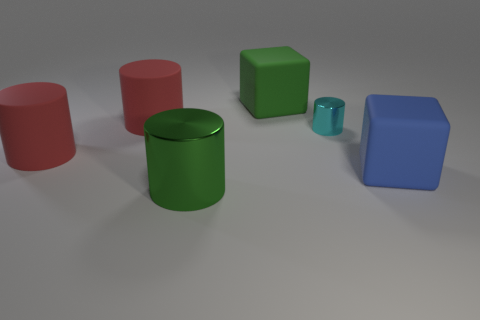What size is the rubber cylinder that is behind the small metal cylinder?
Your answer should be very brief. Large. What is the shape of the green object behind the shiny cylinder in front of the blue matte object?
Keep it short and to the point. Cube. There is a tiny thing that is the same shape as the big metallic object; what color is it?
Ensure brevity in your answer.  Cyan. There is a matte block to the left of the cyan shiny cylinder; does it have the same size as the large green shiny object?
Your answer should be compact. Yes. The rubber object that is the same color as the big shiny thing is what shape?
Keep it short and to the point. Cube. How many brown balls are made of the same material as the large green cube?
Keep it short and to the point. 0. What material is the large thing that is to the right of the cube that is on the left side of the rubber thing that is right of the green matte cube?
Your response must be concise. Rubber. What is the color of the shiny cylinder that is behind the object to the right of the small cyan cylinder?
Ensure brevity in your answer.  Cyan. What is the color of the metal cylinder that is the same size as the blue object?
Offer a terse response. Green. What number of small things are cyan things or rubber cylinders?
Offer a very short reply. 1. 